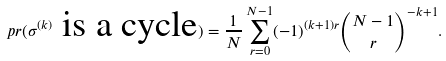<formula> <loc_0><loc_0><loc_500><loc_500>\ p r ( \sigma ^ { ( k ) } \text { is a cycle} ) = \frac { 1 } { N } \sum _ { r = 0 } ^ { N - 1 } ( - 1 ) ^ { ( k + 1 ) r } \binom { N - 1 } { r } ^ { - k + 1 } .</formula> 